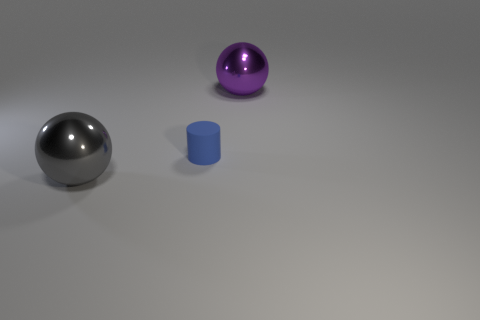How many big things are either matte things or cyan rubber objects?
Offer a very short reply. 0. What is the color of the other big object that is the same material as the purple object?
Provide a succinct answer. Gray. There is a big thing that is to the left of the big purple metallic thing; does it have the same shape as the shiny object to the right of the matte cylinder?
Provide a short and direct response. Yes. What number of metallic objects are big purple things or large spheres?
Your answer should be very brief. 2. Is there anything else that has the same shape as the big gray object?
Provide a short and direct response. Yes. What is the large sphere that is to the left of the matte thing made of?
Your response must be concise. Metal. Are the ball to the left of the blue object and the small blue cylinder made of the same material?
Give a very brief answer. No. What number of objects are either purple objects or objects in front of the big purple metal sphere?
Provide a short and direct response. 3. The other shiny object that is the same shape as the large gray metal thing is what size?
Ensure brevity in your answer.  Large. Is there any other thing that has the same size as the blue cylinder?
Offer a very short reply. No. 